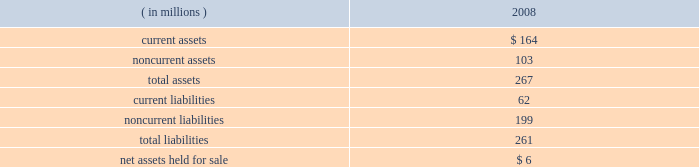Marathon oil corporation notes to consolidated financial statements 7 .
Dispositions outside-operated norwegian properties 2013 on october 31 , 2008 , we closed the sale of our norwegian outside-operated properties and undeveloped offshore acreage in the heimdal area of the norwegian north sea for net proceeds of $ 301 million , with a pretax gain of $ 254 million as of december 31 , 2008 .
Pilot travel centers 2013 on october 8 , 2008 , we completed the sale of our 50 percent ownership interest in ptc .
Sale proceeds were $ 625 million , with a pretax gain on the sale of $ 126 million .
Immediately preceding the sale , we received a $ 75 million partial redemption of our ownership interest from ptc that was accounted for as a return of investment .
Operated irish properties 2013 on december 17 , 2008 , we agreed to sell our operated properties located in ireland for proceeds of $ 180 million , before post-closing adjustments and cash on hand at closing .
Closing is subject to completion of the necessary administrative processes .
As of december 31 , 2008 , operating assets and liabilities were classified as held for sale , as disclosed by major class in the table : ( in millions ) 2008 .
Discontinued operations on june 2 , 2006 , we sold our russian oil exploration and production businesses in the khanty-mansiysk region of western siberia .
Under the terms of the agreement , we received $ 787 million for these businesses , plus preliminary working capital and other closing adjustments of $ 56 million , for a total transaction value of $ 843 million .
Proceeds net of transaction costs and cash held by the russian businesses at the transaction date totaled $ 832 million .
A gain on the sale of $ 243 million ( $ 342 million before income taxes ) was reported in discontinued operations for 2006 .
Income taxes on this gain were reduced by the utilization of a capital loss carryforward .
Exploration and production segment goodwill of $ 21 million was allocated to the russian assets and reduced the reported gain .
Adjustments to the sales price were completed in 2007 and an additional gain on the sale of $ 8 million ( $ 13 million before income taxes ) was recognized .
The activities of the russian businesses have been reported as discontinued operations in the consolidated statements of income and the consolidated statements of cash flows for 2006 .
Revenues applicable to discontinued operations were $ 173 million and pretax income from discontinued operations was $ 45 million for 2006. .
For the russian businesses transaction , what was the tax effect of the gain on the sale of $ 243 million reported in discontinued operations for 2006? 
Computations: (342 - 243)
Answer: 99.0. 